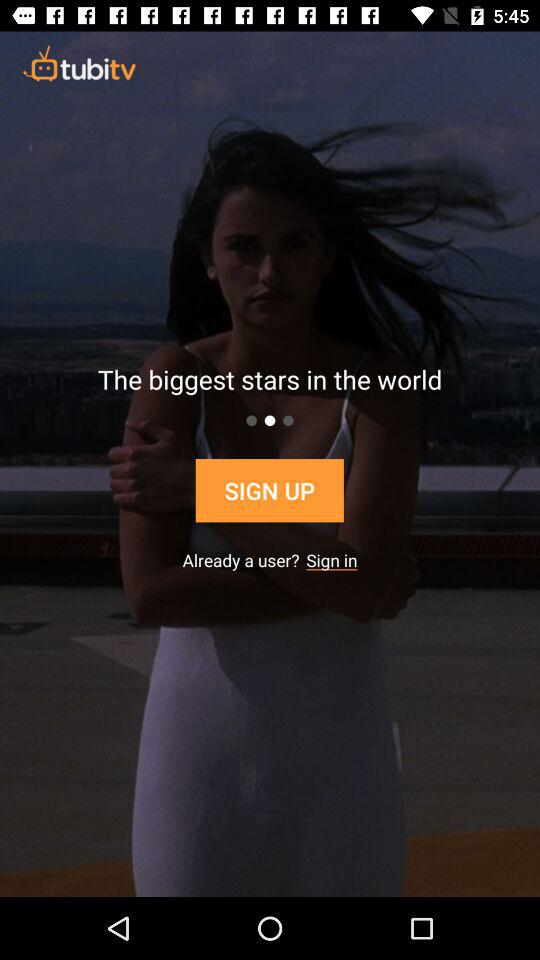What is the app name? The app name is "tubitv". 